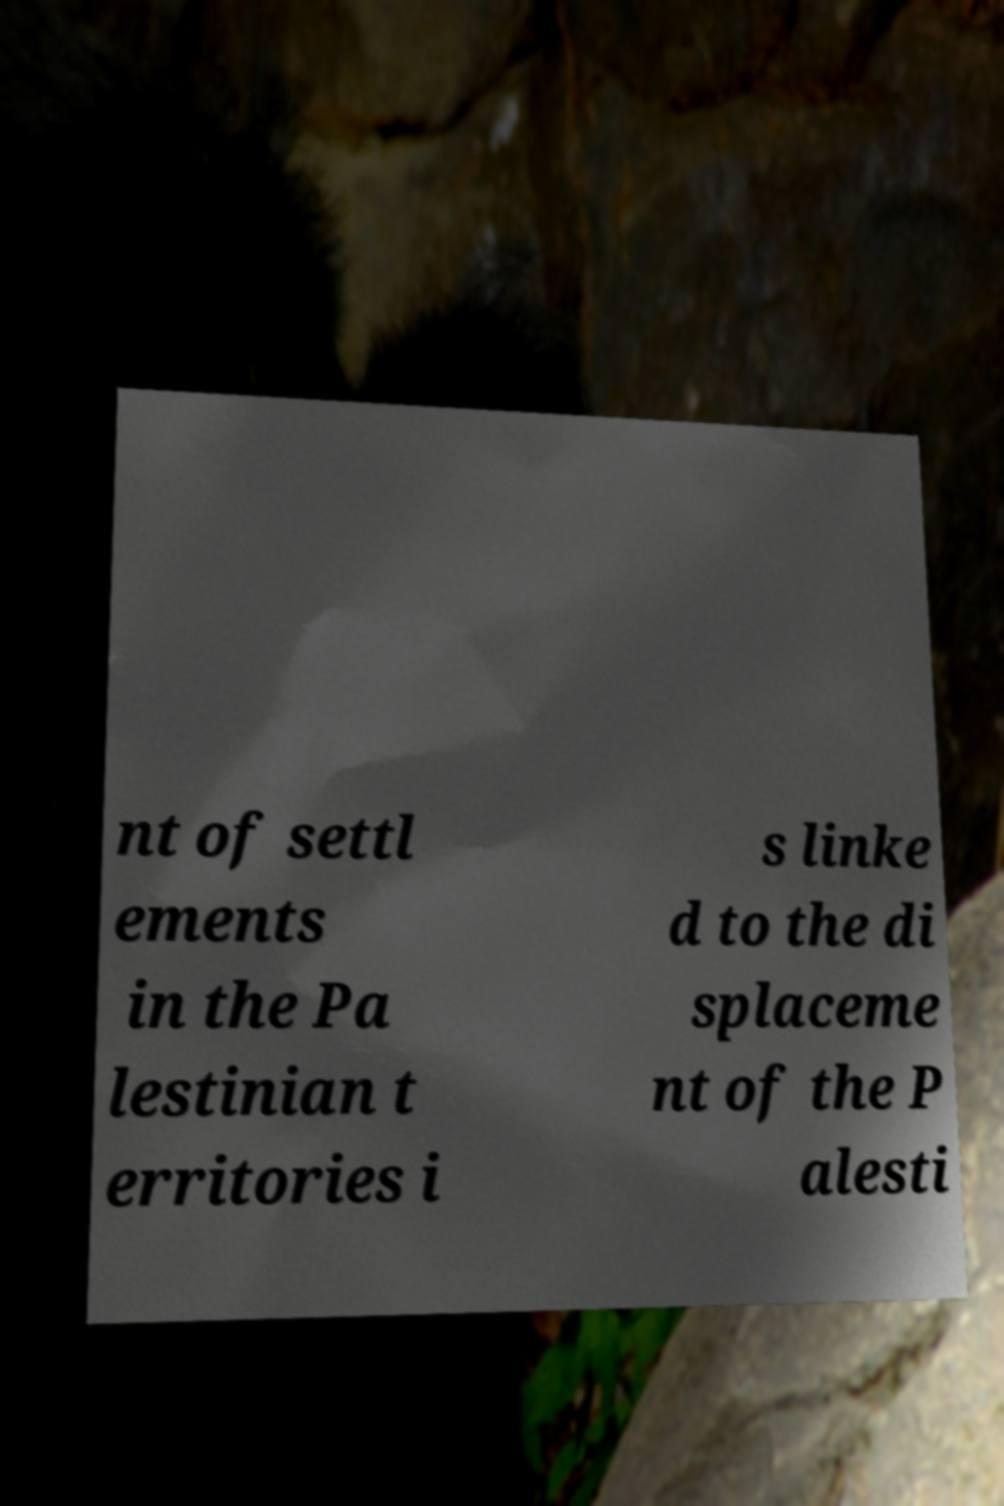I need the written content from this picture converted into text. Can you do that? nt of settl ements in the Pa lestinian t erritories i s linke d to the di splaceme nt of the P alesti 